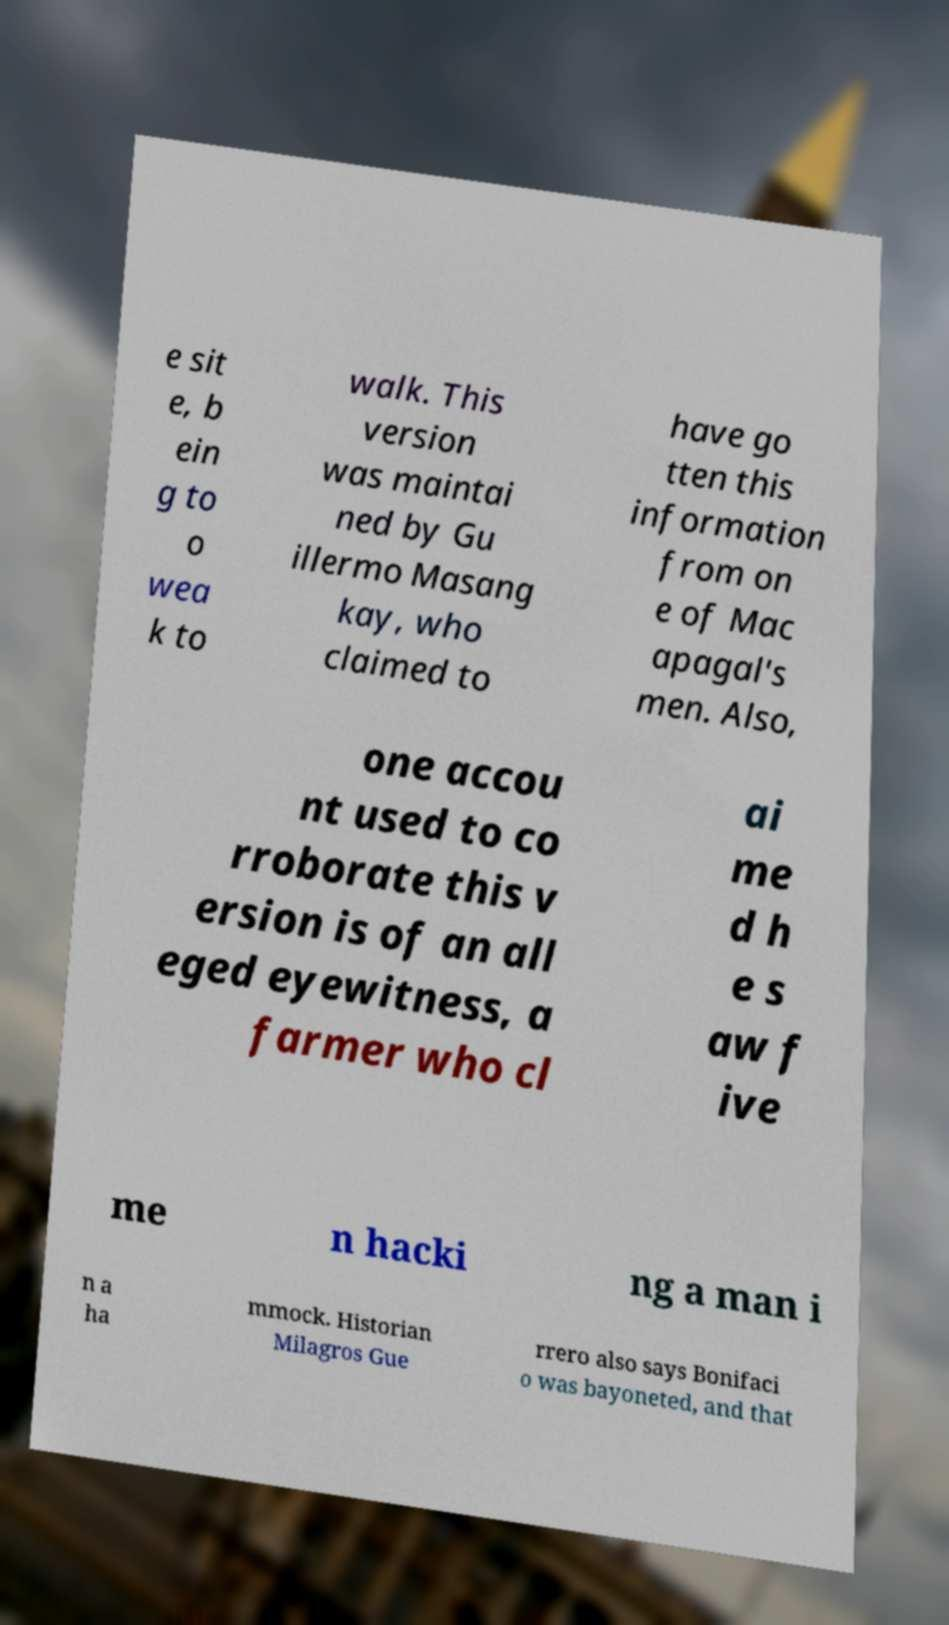Can you read and provide the text displayed in the image?This photo seems to have some interesting text. Can you extract and type it out for me? e sit e, b ein g to o wea k to walk. This version was maintai ned by Gu illermo Masang kay, who claimed to have go tten this information from on e of Mac apagal's men. Also, one accou nt used to co rroborate this v ersion is of an all eged eyewitness, a farmer who cl ai me d h e s aw f ive me n hacki ng a man i n a ha mmock. Historian Milagros Gue rrero also says Bonifaci o was bayoneted, and that 